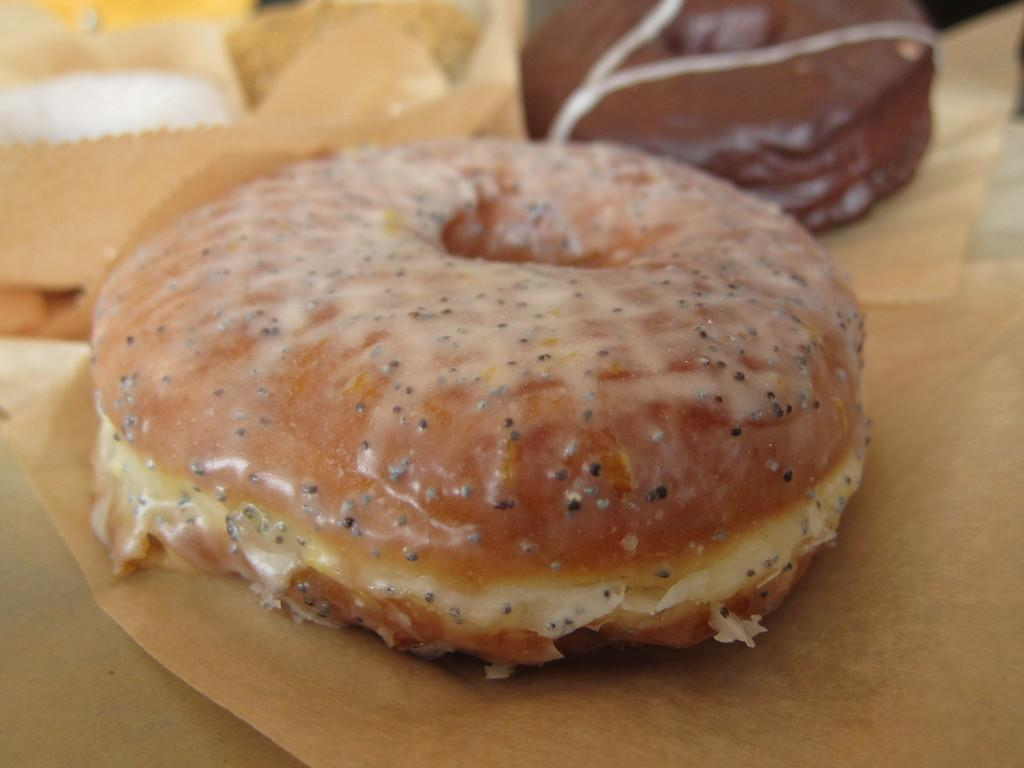How many donuts are visible in the image? There are 2 donuts in the image. What is the surface on which the donuts are placed? The donuts are on a brown surface. Can you describe the background of the image? The background of the image is a bit blurred. What is the color of the object in the top left corner of the image? The object in the top left corner of the image is white. Reasoning: Let's think step by following the guidelines to produce the conversation. We start by identifying the main subject in the image, which is the donuts. Then, we expand the conversation to include other details about the image, such as the surface, background, and the white object in the top left corner. Each question is designed to elicit a specific detail about the image that is known from the provided facts. Absurd Question/Answer: What type of humor can be seen in the image? There is no humor present in the image; it is a simple image of two donuts on a brown surface. 